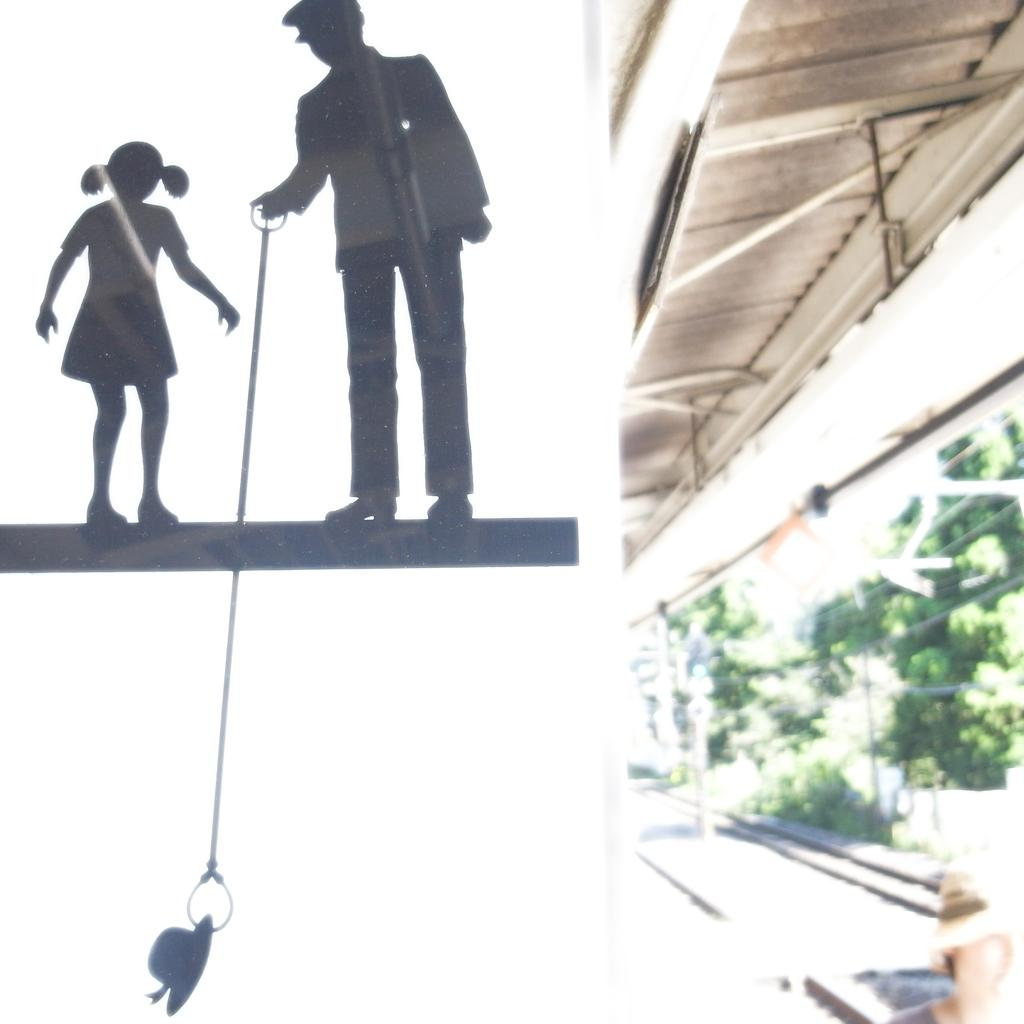Who is in the image? There is a girl and a person in the image. What is the person holding? The person is holding a rope. What is the rope attached to? The rope is attached to a hat. What can be seen on the right side of the image? There are trees on the right side of the image. What is visible in the background of the image? The sky is visible in the image. How many zippers are visible on the girl's clothing in the image? There is no mention of zippers in the image, so it is impossible to determine how many are visible on the girl's clothing. 